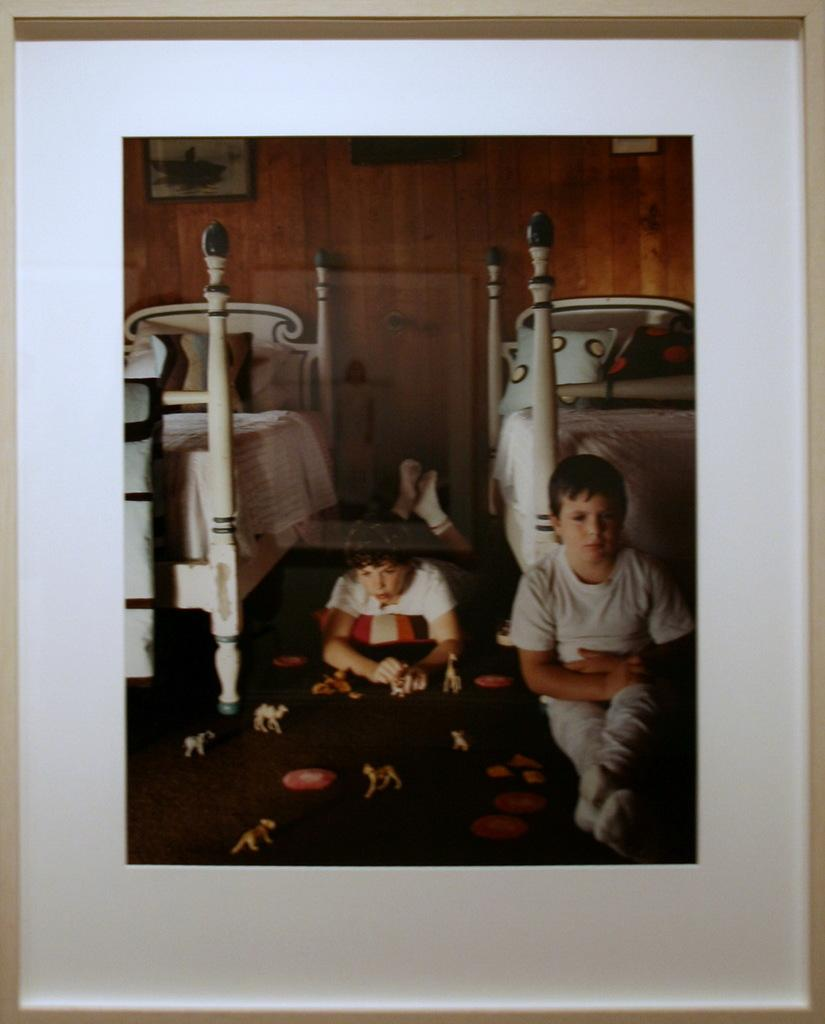What object in the image contains a picture? There is a photo frame in the image that contains a picture. Who or what is depicted in the picture inside the photo frame? The picture inside the photo frame contains a picture of two people. How many beds are visible in the image? There are two beds in the image. How many eyes can be seen on the lizards in the image? There are no lizards present in the image, so the number of eyes cannot be determined. 